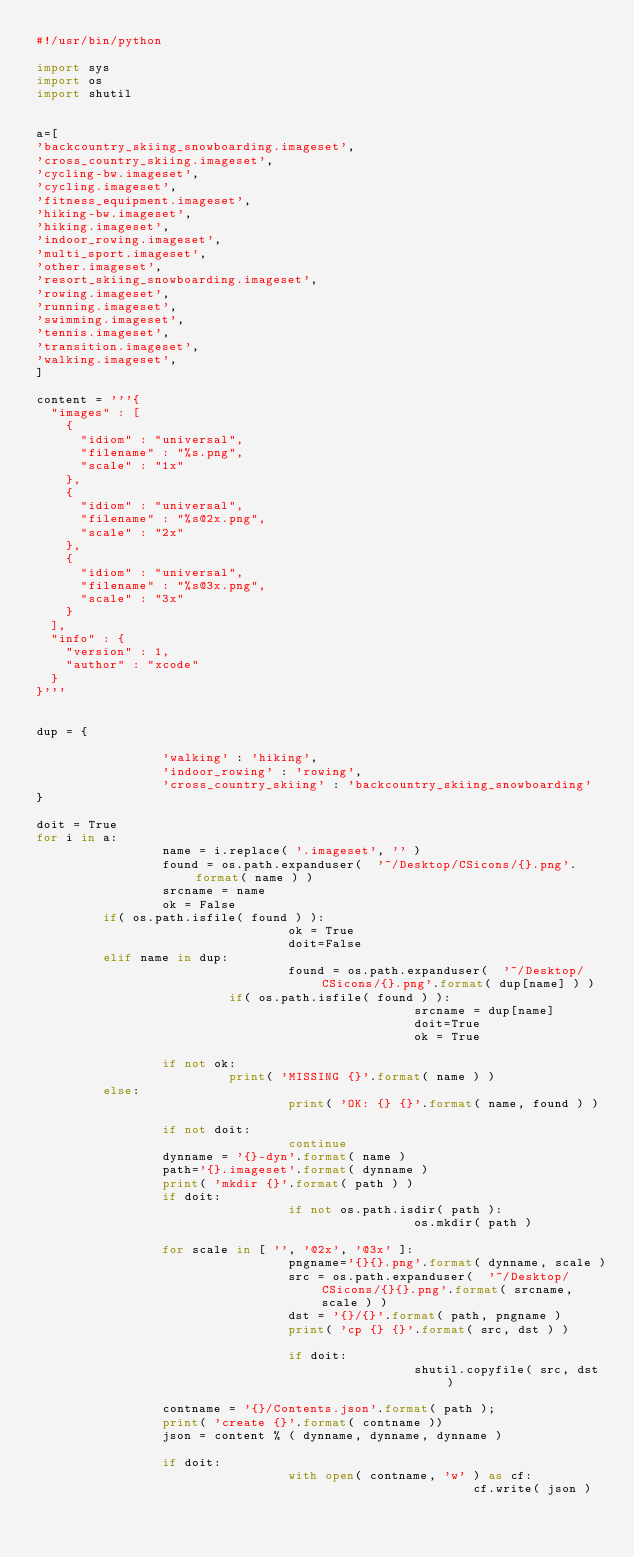<code> <loc_0><loc_0><loc_500><loc_500><_Python_>#!/usr/bin/python

import sys
import os
import shutil


a=[
'backcountry_skiing_snowboarding.imageset',
'cross_country_skiing.imageset',
'cycling-bw.imageset',
'cycling.imageset',
'fitness_equipment.imageset',
'hiking-bw.imageset',
'hiking.imageset',
'indoor_rowing.imageset',
'multi_sport.imageset',
'other.imageset',
'resort_skiing_snowboarding.imageset',
'rowing.imageset',
'running.imageset',
'swimming.imageset',
'tennis.imageset',
'transition.imageset',
'walking.imageset',
]

content = '''{
  "images" : [
    {
      "idiom" : "universal",
      "filename" : "%s.png",
      "scale" : "1x"
    },
    {
      "idiom" : "universal",
      "filename" : "%s@2x.png",
      "scale" : "2x"
    },
    {
      "idiom" : "universal",
      "filename" : "%s@3x.png",
      "scale" : "3x"
    }
  ],
  "info" : {
    "version" : 1,
    "author" : "xcode"
  }
}'''


dup = {

                 'walking' : 'hiking',
                 'indoor_rowing' : 'rowing',
                 'cross_country_skiing' : 'backcountry_skiing_snowboarding'
}

doit = True
for i in a:
                 name = i.replace( '.imageset', '' )
                 found = os.path.expanduser(  '~/Desktop/CSicons/{}.png'.format( name ) )
                 srcname = name
                 ok = False
		 if( os.path.isfile( found ) ):
                                  ok = True
                                  doit=False
		 elif name in dup:
                                  found = os.path.expanduser(  '~/Desktop/CSicons/{}.png'.format( dup[name] ) )
		                  if( os.path.isfile( found ) ):
                                                   srcname = dup[name]
                                                   doit=True
                                                   ok = True

                 if not ok:
		                  print( 'MISSING {}'.format( name ) )
		 else:
                                  print( 'OK: {} {}'.format( name, found ) )

                 if not doit:
                                  continue
                 dynname = '{}-dyn'.format( name )
                 path='{}.imageset'.format( dynname )
                 print( 'mkdir {}'.format( path ) )
                 if doit:
                                  if not os.path.isdir( path ):
                                                   os.mkdir( path )
                                                   
                 for scale in [ '', '@2x', '@3x' ]:
                                  pngname='{}{}.png'.format( dynname, scale )
                                  src = os.path.expanduser(  '~/Desktop/CSicons/{}{}.png'.format( srcname, scale ) )
                                  dst = '{}/{}'.format( path, pngname )
                                  print( 'cp {} {}'.format( src, dst ) )

                                  if doit:
                                                   shutil.copyfile( src, dst )

                 contname = '{}/Contents.json'.format( path );
                 print( 'create {}'.format( contname ))
                 json = content % ( dynname, dynname, dynname )

                 if doit:
                                  with open( contname, 'w' ) as cf:
                                                           cf.write( json )
                                                                    

                                  
                        


                 
</code> 